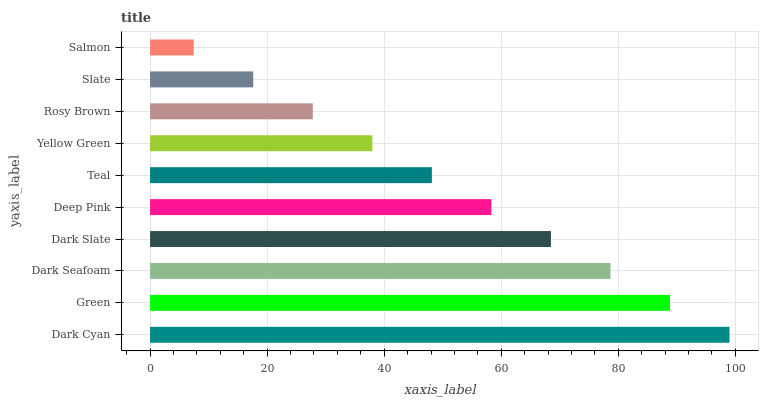Is Salmon the minimum?
Answer yes or no. Yes. Is Dark Cyan the maximum?
Answer yes or no. Yes. Is Green the minimum?
Answer yes or no. No. Is Green the maximum?
Answer yes or no. No. Is Dark Cyan greater than Green?
Answer yes or no. Yes. Is Green less than Dark Cyan?
Answer yes or no. Yes. Is Green greater than Dark Cyan?
Answer yes or no. No. Is Dark Cyan less than Green?
Answer yes or no. No. Is Deep Pink the high median?
Answer yes or no. Yes. Is Teal the low median?
Answer yes or no. Yes. Is Dark Seafoam the high median?
Answer yes or no. No. Is Dark Seafoam the low median?
Answer yes or no. No. 